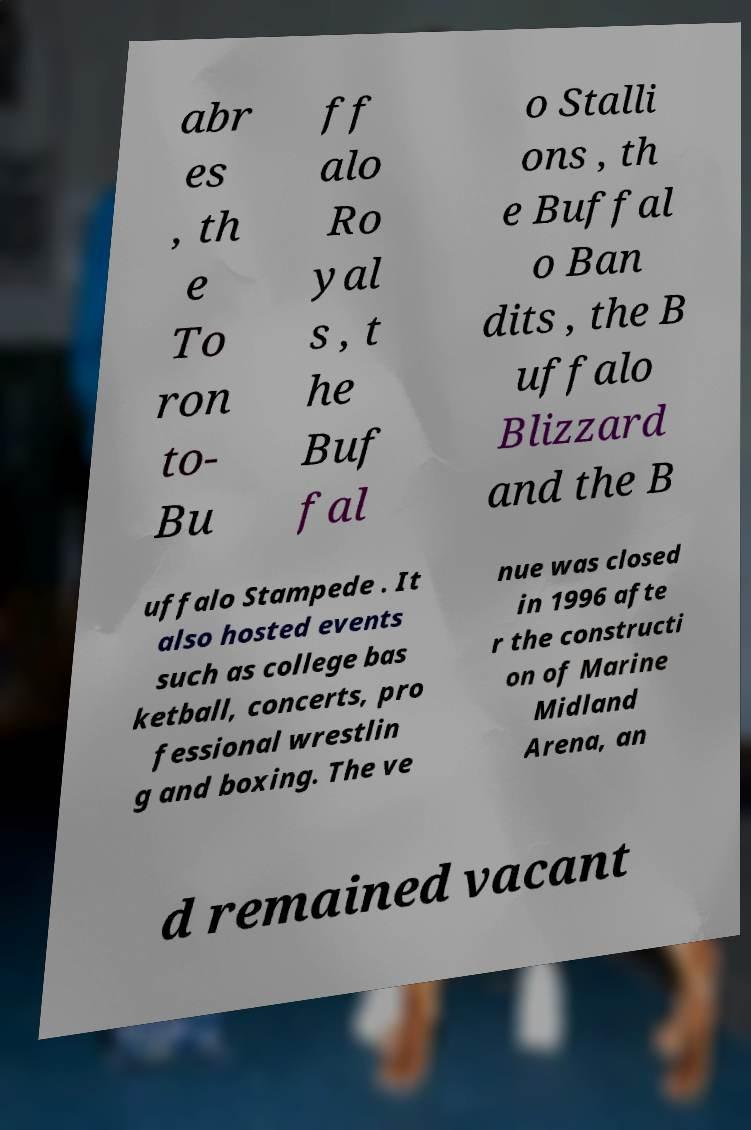Could you extract and type out the text from this image? abr es , th e To ron to- Bu ff alo Ro yal s , t he Buf fal o Stalli ons , th e Buffal o Ban dits , the B uffalo Blizzard and the B uffalo Stampede . It also hosted events such as college bas ketball, concerts, pro fessional wrestlin g and boxing. The ve nue was closed in 1996 afte r the constructi on of Marine Midland Arena, an d remained vacant 